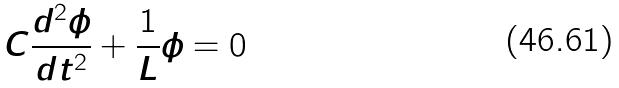<formula> <loc_0><loc_0><loc_500><loc_500>C \frac { d ^ { 2 } \phi } { d t ^ { 2 } } + \frac { 1 } { L } \phi = 0</formula> 